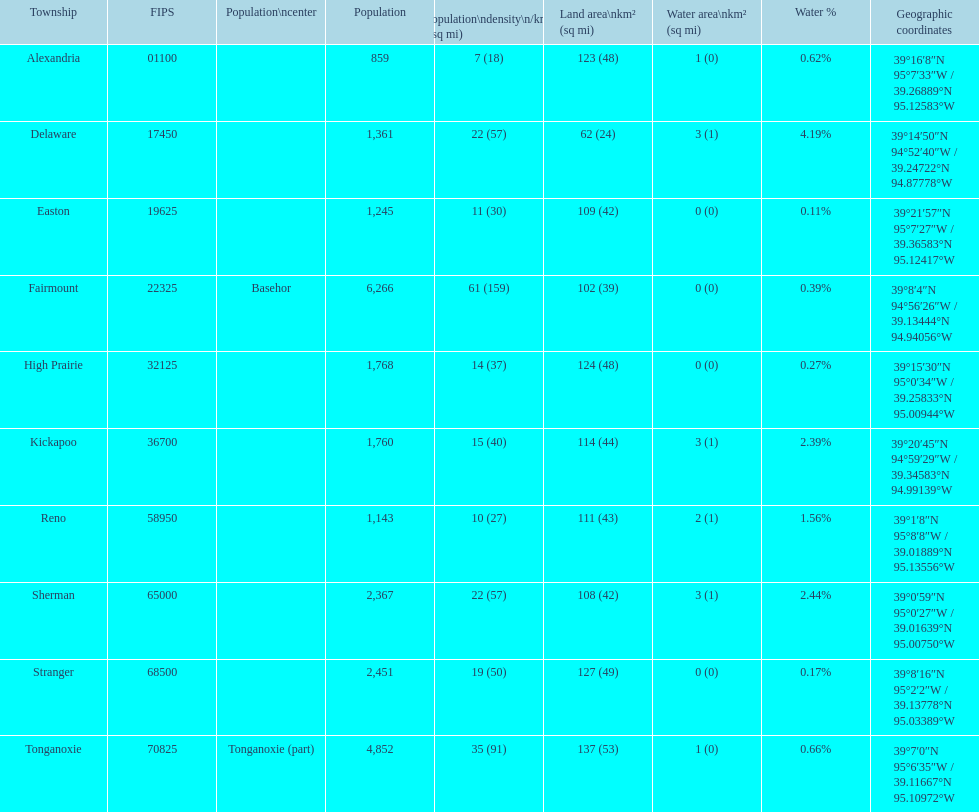What is the count of townships where the population is over 2,000? 4. 